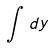<formula> <loc_0><loc_0><loc_500><loc_500>\int d y</formula> 